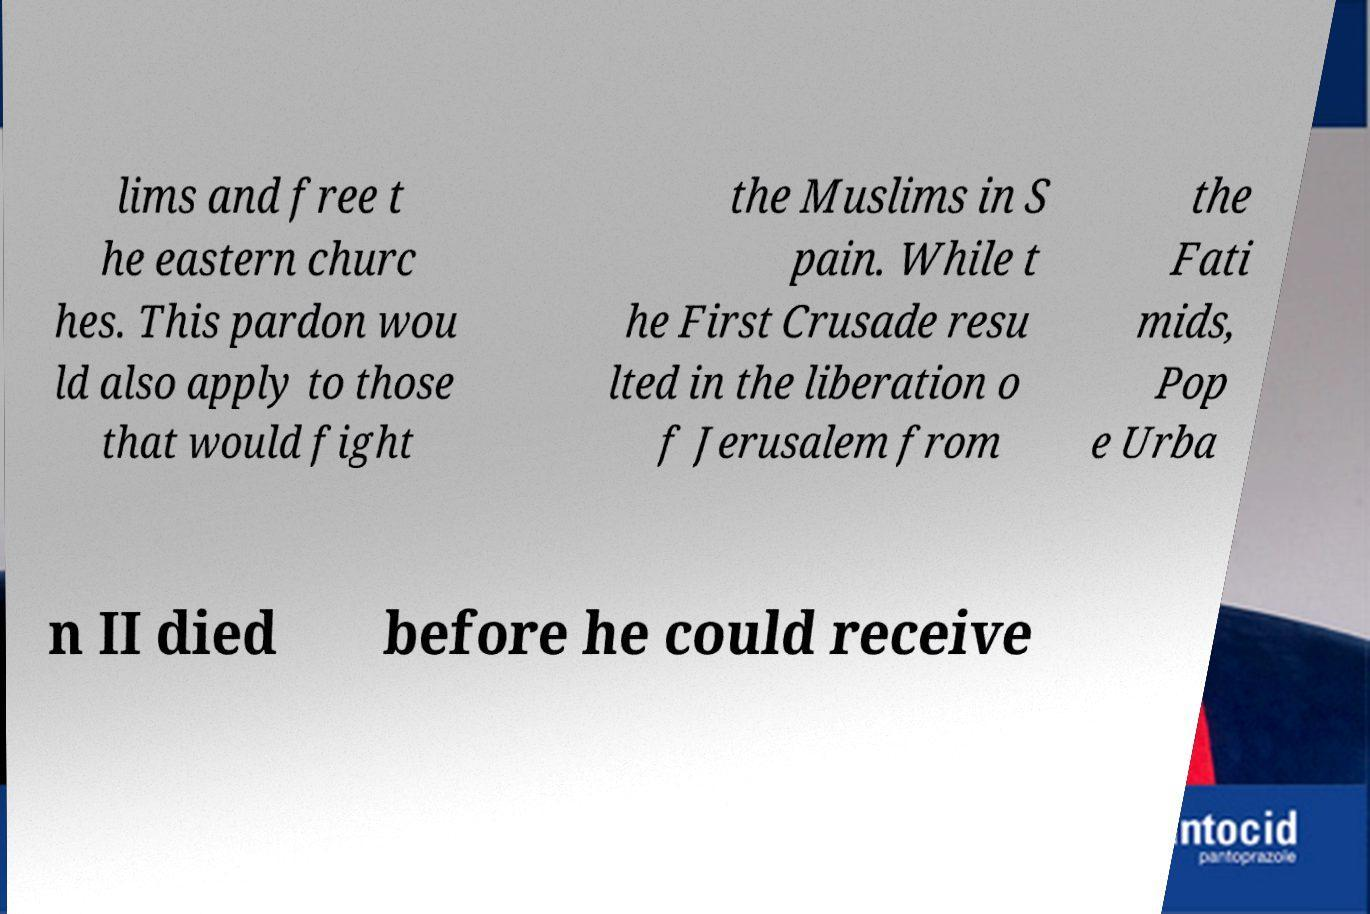Please identify and transcribe the text found in this image. lims and free t he eastern churc hes. This pardon wou ld also apply to those that would fight the Muslims in S pain. While t he First Crusade resu lted in the liberation o f Jerusalem from the Fati mids, Pop e Urba n II died before he could receive 